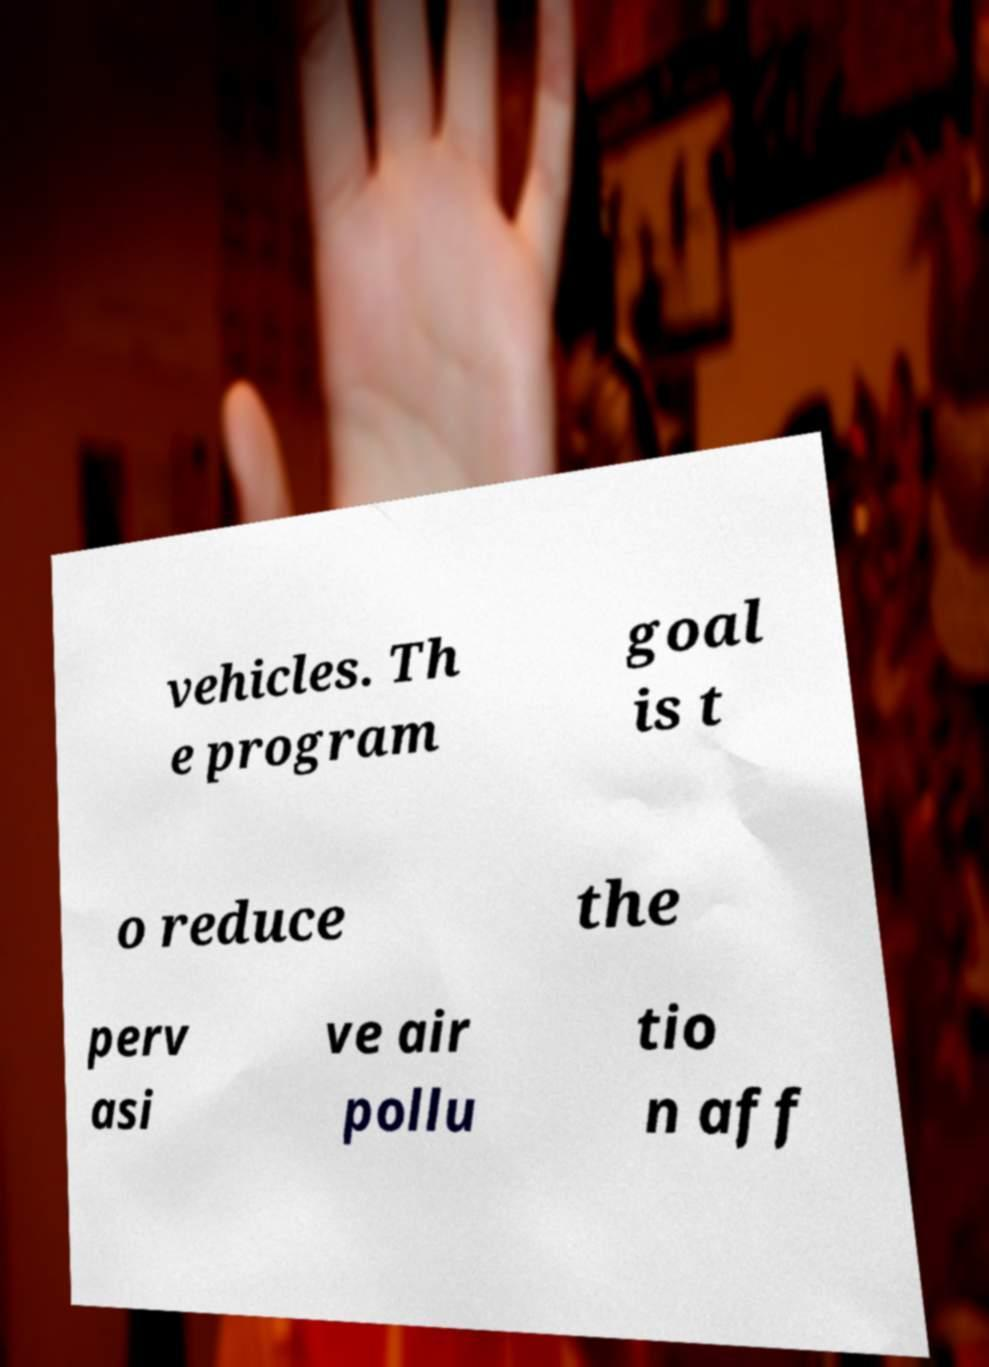I need the written content from this picture converted into text. Can you do that? vehicles. Th e program goal is t o reduce the perv asi ve air pollu tio n aff 